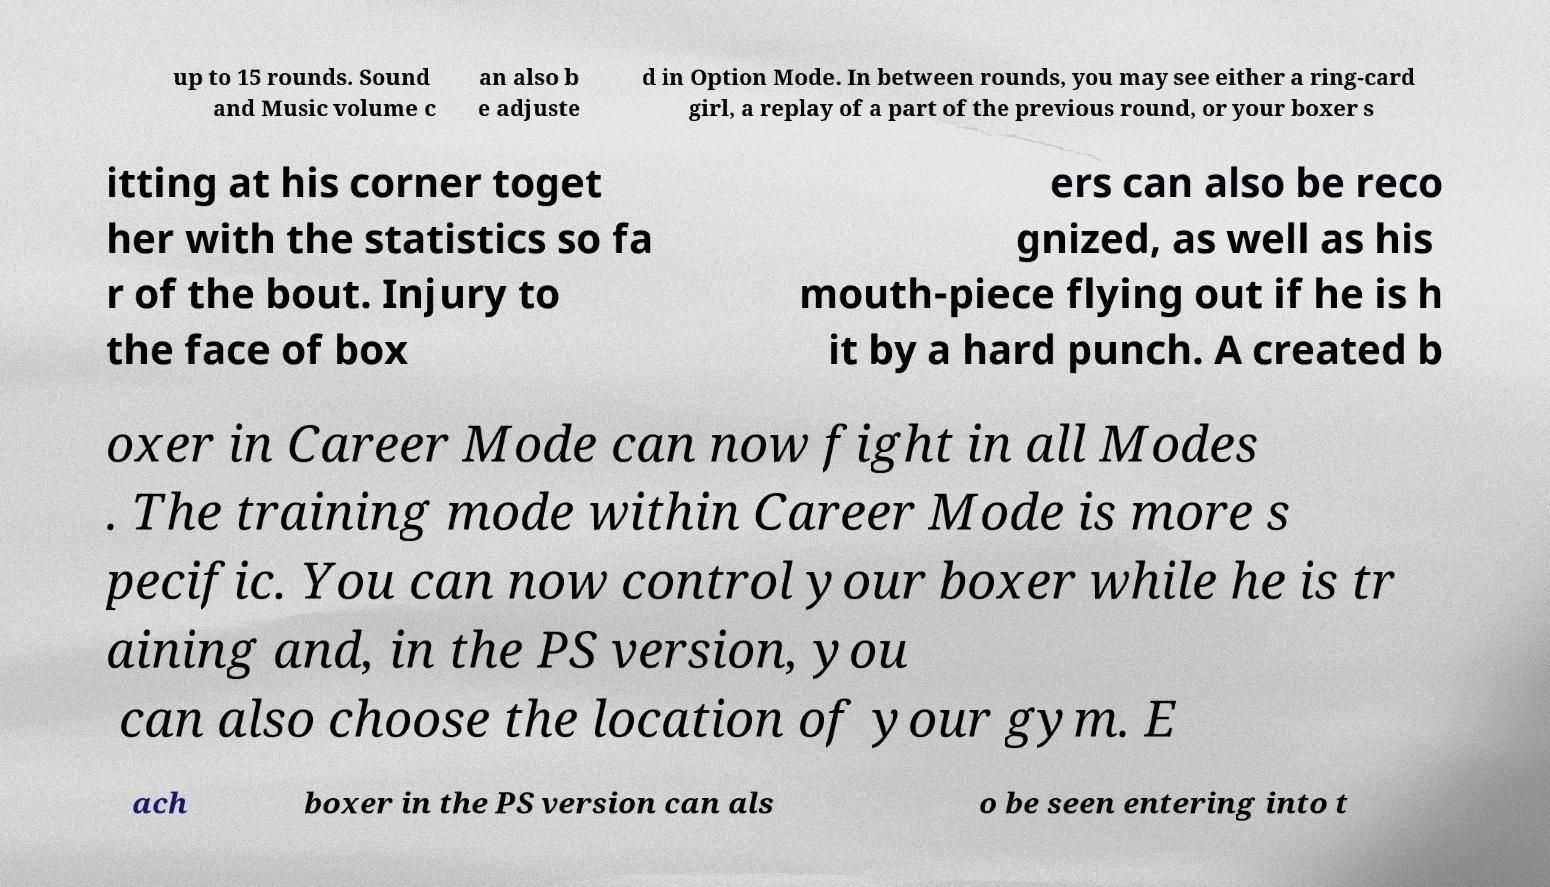Can you read and provide the text displayed in the image?This photo seems to have some interesting text. Can you extract and type it out for me? up to 15 rounds. Sound and Music volume c an also b e adjuste d in Option Mode. In between rounds, you may see either a ring-card girl, a replay of a part of the previous round, or your boxer s itting at his corner toget her with the statistics so fa r of the bout. Injury to the face of box ers can also be reco gnized, as well as his mouth-piece flying out if he is h it by a hard punch. A created b oxer in Career Mode can now fight in all Modes . The training mode within Career Mode is more s pecific. You can now control your boxer while he is tr aining and, in the PS version, you can also choose the location of your gym. E ach boxer in the PS version can als o be seen entering into t 